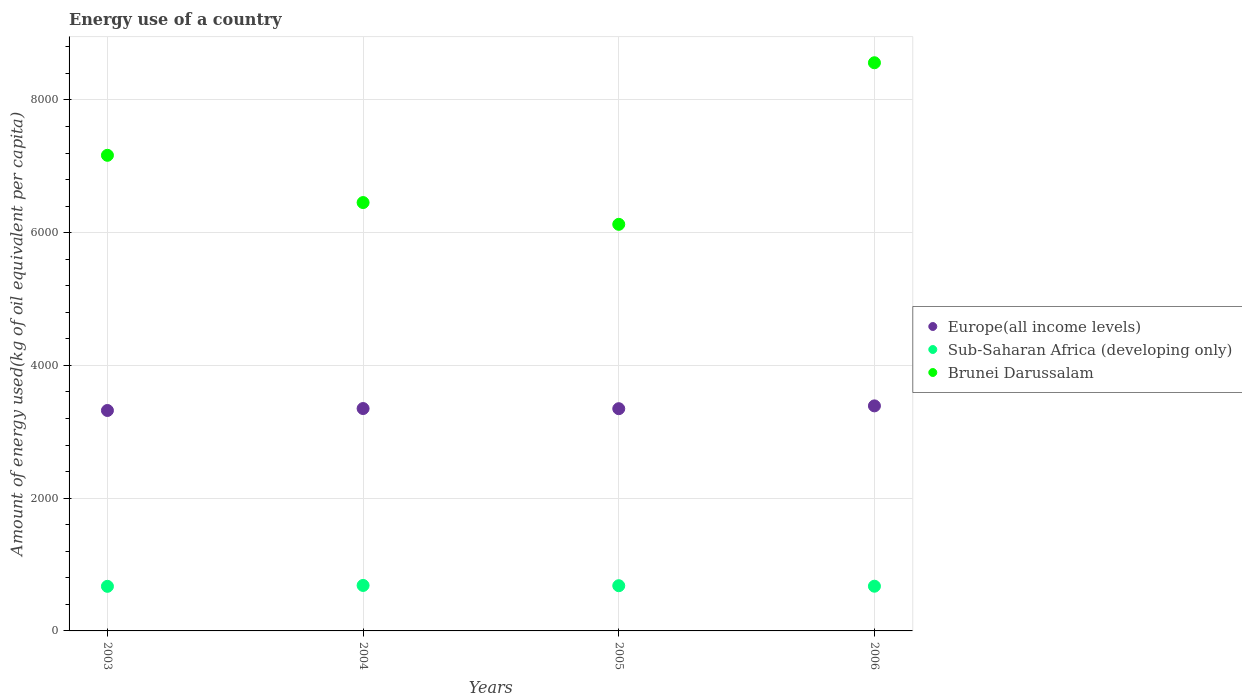How many different coloured dotlines are there?
Make the answer very short. 3. Is the number of dotlines equal to the number of legend labels?
Your answer should be compact. Yes. What is the amount of energy used in in Europe(all income levels) in 2005?
Provide a succinct answer. 3348.29. Across all years, what is the maximum amount of energy used in in Europe(all income levels)?
Give a very brief answer. 3390.69. Across all years, what is the minimum amount of energy used in in Sub-Saharan Africa (developing only)?
Your answer should be compact. 671.88. In which year was the amount of energy used in in Brunei Darussalam maximum?
Offer a very short reply. 2006. What is the total amount of energy used in in Brunei Darussalam in the graph?
Make the answer very short. 2.83e+04. What is the difference between the amount of energy used in in Brunei Darussalam in 2003 and that in 2006?
Keep it short and to the point. -1394.4. What is the difference between the amount of energy used in in Brunei Darussalam in 2004 and the amount of energy used in in Sub-Saharan Africa (developing only) in 2003?
Ensure brevity in your answer.  5782.13. What is the average amount of energy used in in Brunei Darussalam per year?
Your answer should be compact. 7076.58. In the year 2005, what is the difference between the amount of energy used in in Brunei Darussalam and amount of energy used in in Sub-Saharan Africa (developing only)?
Keep it short and to the point. 5444.76. What is the ratio of the amount of energy used in in Brunei Darussalam in 2004 to that in 2006?
Provide a short and direct response. 0.75. Is the amount of energy used in in Europe(all income levels) in 2004 less than that in 2005?
Offer a very short reply. No. What is the difference between the highest and the second highest amount of energy used in in Brunei Darussalam?
Offer a terse response. 1394.4. What is the difference between the highest and the lowest amount of energy used in in Brunei Darussalam?
Ensure brevity in your answer.  2434.55. In how many years, is the amount of energy used in in Europe(all income levels) greater than the average amount of energy used in in Europe(all income levels) taken over all years?
Offer a terse response. 1. Is the amount of energy used in in Brunei Darussalam strictly greater than the amount of energy used in in Sub-Saharan Africa (developing only) over the years?
Make the answer very short. Yes. How many dotlines are there?
Offer a terse response. 3. Are the values on the major ticks of Y-axis written in scientific E-notation?
Your answer should be very brief. No. Does the graph contain grids?
Make the answer very short. Yes. Where does the legend appear in the graph?
Your answer should be compact. Center right. How many legend labels are there?
Your answer should be compact. 3. What is the title of the graph?
Your response must be concise. Energy use of a country. Does "Zimbabwe" appear as one of the legend labels in the graph?
Provide a succinct answer. No. What is the label or title of the X-axis?
Your answer should be very brief. Years. What is the label or title of the Y-axis?
Provide a succinct answer. Amount of energy used(kg of oil equivalent per capita). What is the Amount of energy used(kg of oil equivalent per capita) of Europe(all income levels) in 2003?
Give a very brief answer. 3321.23. What is the Amount of energy used(kg of oil equivalent per capita) of Sub-Saharan Africa (developing only) in 2003?
Offer a terse response. 671.88. What is the Amount of energy used(kg of oil equivalent per capita) in Brunei Darussalam in 2003?
Give a very brief answer. 7166.03. What is the Amount of energy used(kg of oil equivalent per capita) in Europe(all income levels) in 2004?
Give a very brief answer. 3350.61. What is the Amount of energy used(kg of oil equivalent per capita) of Sub-Saharan Africa (developing only) in 2004?
Your response must be concise. 685.23. What is the Amount of energy used(kg of oil equivalent per capita) of Brunei Darussalam in 2004?
Ensure brevity in your answer.  6454. What is the Amount of energy used(kg of oil equivalent per capita) of Europe(all income levels) in 2005?
Give a very brief answer. 3348.29. What is the Amount of energy used(kg of oil equivalent per capita) in Sub-Saharan Africa (developing only) in 2005?
Give a very brief answer. 681.12. What is the Amount of energy used(kg of oil equivalent per capita) in Brunei Darussalam in 2005?
Provide a short and direct response. 6125.88. What is the Amount of energy used(kg of oil equivalent per capita) of Europe(all income levels) in 2006?
Your answer should be very brief. 3390.69. What is the Amount of energy used(kg of oil equivalent per capita) in Sub-Saharan Africa (developing only) in 2006?
Your response must be concise. 673.61. What is the Amount of energy used(kg of oil equivalent per capita) in Brunei Darussalam in 2006?
Your answer should be very brief. 8560.43. Across all years, what is the maximum Amount of energy used(kg of oil equivalent per capita) of Europe(all income levels)?
Make the answer very short. 3390.69. Across all years, what is the maximum Amount of energy used(kg of oil equivalent per capita) in Sub-Saharan Africa (developing only)?
Your response must be concise. 685.23. Across all years, what is the maximum Amount of energy used(kg of oil equivalent per capita) in Brunei Darussalam?
Offer a very short reply. 8560.43. Across all years, what is the minimum Amount of energy used(kg of oil equivalent per capita) in Europe(all income levels)?
Your response must be concise. 3321.23. Across all years, what is the minimum Amount of energy used(kg of oil equivalent per capita) of Sub-Saharan Africa (developing only)?
Your response must be concise. 671.88. Across all years, what is the minimum Amount of energy used(kg of oil equivalent per capita) in Brunei Darussalam?
Your answer should be compact. 6125.88. What is the total Amount of energy used(kg of oil equivalent per capita) of Europe(all income levels) in the graph?
Ensure brevity in your answer.  1.34e+04. What is the total Amount of energy used(kg of oil equivalent per capita) of Sub-Saharan Africa (developing only) in the graph?
Provide a succinct answer. 2711.84. What is the total Amount of energy used(kg of oil equivalent per capita) in Brunei Darussalam in the graph?
Your answer should be compact. 2.83e+04. What is the difference between the Amount of energy used(kg of oil equivalent per capita) in Europe(all income levels) in 2003 and that in 2004?
Offer a terse response. -29.38. What is the difference between the Amount of energy used(kg of oil equivalent per capita) of Sub-Saharan Africa (developing only) in 2003 and that in 2004?
Offer a very short reply. -13.36. What is the difference between the Amount of energy used(kg of oil equivalent per capita) of Brunei Darussalam in 2003 and that in 2004?
Make the answer very short. 712.02. What is the difference between the Amount of energy used(kg of oil equivalent per capita) of Europe(all income levels) in 2003 and that in 2005?
Give a very brief answer. -27.07. What is the difference between the Amount of energy used(kg of oil equivalent per capita) in Sub-Saharan Africa (developing only) in 2003 and that in 2005?
Give a very brief answer. -9.25. What is the difference between the Amount of energy used(kg of oil equivalent per capita) of Brunei Darussalam in 2003 and that in 2005?
Ensure brevity in your answer.  1040.15. What is the difference between the Amount of energy used(kg of oil equivalent per capita) of Europe(all income levels) in 2003 and that in 2006?
Provide a short and direct response. -69.46. What is the difference between the Amount of energy used(kg of oil equivalent per capita) in Sub-Saharan Africa (developing only) in 2003 and that in 2006?
Keep it short and to the point. -1.74. What is the difference between the Amount of energy used(kg of oil equivalent per capita) of Brunei Darussalam in 2003 and that in 2006?
Offer a very short reply. -1394.4. What is the difference between the Amount of energy used(kg of oil equivalent per capita) in Europe(all income levels) in 2004 and that in 2005?
Offer a terse response. 2.31. What is the difference between the Amount of energy used(kg of oil equivalent per capita) of Sub-Saharan Africa (developing only) in 2004 and that in 2005?
Your answer should be very brief. 4.11. What is the difference between the Amount of energy used(kg of oil equivalent per capita) in Brunei Darussalam in 2004 and that in 2005?
Make the answer very short. 328.12. What is the difference between the Amount of energy used(kg of oil equivalent per capita) of Europe(all income levels) in 2004 and that in 2006?
Your answer should be very brief. -40.08. What is the difference between the Amount of energy used(kg of oil equivalent per capita) in Sub-Saharan Africa (developing only) in 2004 and that in 2006?
Give a very brief answer. 11.62. What is the difference between the Amount of energy used(kg of oil equivalent per capita) in Brunei Darussalam in 2004 and that in 2006?
Your response must be concise. -2106.42. What is the difference between the Amount of energy used(kg of oil equivalent per capita) in Europe(all income levels) in 2005 and that in 2006?
Your answer should be compact. -42.39. What is the difference between the Amount of energy used(kg of oil equivalent per capita) in Sub-Saharan Africa (developing only) in 2005 and that in 2006?
Provide a succinct answer. 7.51. What is the difference between the Amount of energy used(kg of oil equivalent per capita) of Brunei Darussalam in 2005 and that in 2006?
Give a very brief answer. -2434.55. What is the difference between the Amount of energy used(kg of oil equivalent per capita) of Europe(all income levels) in 2003 and the Amount of energy used(kg of oil equivalent per capita) of Sub-Saharan Africa (developing only) in 2004?
Your response must be concise. 2635.99. What is the difference between the Amount of energy used(kg of oil equivalent per capita) of Europe(all income levels) in 2003 and the Amount of energy used(kg of oil equivalent per capita) of Brunei Darussalam in 2004?
Your answer should be compact. -3132.78. What is the difference between the Amount of energy used(kg of oil equivalent per capita) in Sub-Saharan Africa (developing only) in 2003 and the Amount of energy used(kg of oil equivalent per capita) in Brunei Darussalam in 2004?
Offer a very short reply. -5782.13. What is the difference between the Amount of energy used(kg of oil equivalent per capita) of Europe(all income levels) in 2003 and the Amount of energy used(kg of oil equivalent per capita) of Sub-Saharan Africa (developing only) in 2005?
Your answer should be very brief. 2640.1. What is the difference between the Amount of energy used(kg of oil equivalent per capita) in Europe(all income levels) in 2003 and the Amount of energy used(kg of oil equivalent per capita) in Brunei Darussalam in 2005?
Your answer should be very brief. -2804.66. What is the difference between the Amount of energy used(kg of oil equivalent per capita) of Sub-Saharan Africa (developing only) in 2003 and the Amount of energy used(kg of oil equivalent per capita) of Brunei Darussalam in 2005?
Provide a succinct answer. -5454.01. What is the difference between the Amount of energy used(kg of oil equivalent per capita) of Europe(all income levels) in 2003 and the Amount of energy used(kg of oil equivalent per capita) of Sub-Saharan Africa (developing only) in 2006?
Your answer should be compact. 2647.61. What is the difference between the Amount of energy used(kg of oil equivalent per capita) in Europe(all income levels) in 2003 and the Amount of energy used(kg of oil equivalent per capita) in Brunei Darussalam in 2006?
Offer a very short reply. -5239.2. What is the difference between the Amount of energy used(kg of oil equivalent per capita) in Sub-Saharan Africa (developing only) in 2003 and the Amount of energy used(kg of oil equivalent per capita) in Brunei Darussalam in 2006?
Your answer should be very brief. -7888.55. What is the difference between the Amount of energy used(kg of oil equivalent per capita) in Europe(all income levels) in 2004 and the Amount of energy used(kg of oil equivalent per capita) in Sub-Saharan Africa (developing only) in 2005?
Offer a very short reply. 2669.49. What is the difference between the Amount of energy used(kg of oil equivalent per capita) of Europe(all income levels) in 2004 and the Amount of energy used(kg of oil equivalent per capita) of Brunei Darussalam in 2005?
Offer a terse response. -2775.27. What is the difference between the Amount of energy used(kg of oil equivalent per capita) in Sub-Saharan Africa (developing only) in 2004 and the Amount of energy used(kg of oil equivalent per capita) in Brunei Darussalam in 2005?
Ensure brevity in your answer.  -5440.65. What is the difference between the Amount of energy used(kg of oil equivalent per capita) in Europe(all income levels) in 2004 and the Amount of energy used(kg of oil equivalent per capita) in Sub-Saharan Africa (developing only) in 2006?
Your answer should be compact. 2676.99. What is the difference between the Amount of energy used(kg of oil equivalent per capita) of Europe(all income levels) in 2004 and the Amount of energy used(kg of oil equivalent per capita) of Brunei Darussalam in 2006?
Give a very brief answer. -5209.82. What is the difference between the Amount of energy used(kg of oil equivalent per capita) in Sub-Saharan Africa (developing only) in 2004 and the Amount of energy used(kg of oil equivalent per capita) in Brunei Darussalam in 2006?
Make the answer very short. -7875.19. What is the difference between the Amount of energy used(kg of oil equivalent per capita) of Europe(all income levels) in 2005 and the Amount of energy used(kg of oil equivalent per capita) of Sub-Saharan Africa (developing only) in 2006?
Keep it short and to the point. 2674.68. What is the difference between the Amount of energy used(kg of oil equivalent per capita) in Europe(all income levels) in 2005 and the Amount of energy used(kg of oil equivalent per capita) in Brunei Darussalam in 2006?
Offer a terse response. -5212.13. What is the difference between the Amount of energy used(kg of oil equivalent per capita) in Sub-Saharan Africa (developing only) in 2005 and the Amount of energy used(kg of oil equivalent per capita) in Brunei Darussalam in 2006?
Give a very brief answer. -7879.31. What is the average Amount of energy used(kg of oil equivalent per capita) of Europe(all income levels) per year?
Make the answer very short. 3352.7. What is the average Amount of energy used(kg of oil equivalent per capita) of Sub-Saharan Africa (developing only) per year?
Your response must be concise. 677.96. What is the average Amount of energy used(kg of oil equivalent per capita) in Brunei Darussalam per year?
Offer a very short reply. 7076.58. In the year 2003, what is the difference between the Amount of energy used(kg of oil equivalent per capita) of Europe(all income levels) and Amount of energy used(kg of oil equivalent per capita) of Sub-Saharan Africa (developing only)?
Give a very brief answer. 2649.35. In the year 2003, what is the difference between the Amount of energy used(kg of oil equivalent per capita) of Europe(all income levels) and Amount of energy used(kg of oil equivalent per capita) of Brunei Darussalam?
Give a very brief answer. -3844.8. In the year 2003, what is the difference between the Amount of energy used(kg of oil equivalent per capita) of Sub-Saharan Africa (developing only) and Amount of energy used(kg of oil equivalent per capita) of Brunei Darussalam?
Offer a very short reply. -6494.15. In the year 2004, what is the difference between the Amount of energy used(kg of oil equivalent per capita) of Europe(all income levels) and Amount of energy used(kg of oil equivalent per capita) of Sub-Saharan Africa (developing only)?
Offer a terse response. 2665.38. In the year 2004, what is the difference between the Amount of energy used(kg of oil equivalent per capita) of Europe(all income levels) and Amount of energy used(kg of oil equivalent per capita) of Brunei Darussalam?
Keep it short and to the point. -3103.4. In the year 2004, what is the difference between the Amount of energy used(kg of oil equivalent per capita) of Sub-Saharan Africa (developing only) and Amount of energy used(kg of oil equivalent per capita) of Brunei Darussalam?
Give a very brief answer. -5768.77. In the year 2005, what is the difference between the Amount of energy used(kg of oil equivalent per capita) in Europe(all income levels) and Amount of energy used(kg of oil equivalent per capita) in Sub-Saharan Africa (developing only)?
Your answer should be very brief. 2667.17. In the year 2005, what is the difference between the Amount of energy used(kg of oil equivalent per capita) of Europe(all income levels) and Amount of energy used(kg of oil equivalent per capita) of Brunei Darussalam?
Ensure brevity in your answer.  -2777.59. In the year 2005, what is the difference between the Amount of energy used(kg of oil equivalent per capita) in Sub-Saharan Africa (developing only) and Amount of energy used(kg of oil equivalent per capita) in Brunei Darussalam?
Offer a terse response. -5444.76. In the year 2006, what is the difference between the Amount of energy used(kg of oil equivalent per capita) of Europe(all income levels) and Amount of energy used(kg of oil equivalent per capita) of Sub-Saharan Africa (developing only)?
Give a very brief answer. 2717.07. In the year 2006, what is the difference between the Amount of energy used(kg of oil equivalent per capita) in Europe(all income levels) and Amount of energy used(kg of oil equivalent per capita) in Brunei Darussalam?
Make the answer very short. -5169.74. In the year 2006, what is the difference between the Amount of energy used(kg of oil equivalent per capita) in Sub-Saharan Africa (developing only) and Amount of energy used(kg of oil equivalent per capita) in Brunei Darussalam?
Your response must be concise. -7886.81. What is the ratio of the Amount of energy used(kg of oil equivalent per capita) in Sub-Saharan Africa (developing only) in 2003 to that in 2004?
Your answer should be very brief. 0.98. What is the ratio of the Amount of energy used(kg of oil equivalent per capita) of Brunei Darussalam in 2003 to that in 2004?
Provide a succinct answer. 1.11. What is the ratio of the Amount of energy used(kg of oil equivalent per capita) of Europe(all income levels) in 2003 to that in 2005?
Your response must be concise. 0.99. What is the ratio of the Amount of energy used(kg of oil equivalent per capita) of Sub-Saharan Africa (developing only) in 2003 to that in 2005?
Offer a terse response. 0.99. What is the ratio of the Amount of energy used(kg of oil equivalent per capita) of Brunei Darussalam in 2003 to that in 2005?
Provide a short and direct response. 1.17. What is the ratio of the Amount of energy used(kg of oil equivalent per capita) of Europe(all income levels) in 2003 to that in 2006?
Give a very brief answer. 0.98. What is the ratio of the Amount of energy used(kg of oil equivalent per capita) in Brunei Darussalam in 2003 to that in 2006?
Offer a terse response. 0.84. What is the ratio of the Amount of energy used(kg of oil equivalent per capita) of Europe(all income levels) in 2004 to that in 2005?
Provide a succinct answer. 1. What is the ratio of the Amount of energy used(kg of oil equivalent per capita) in Sub-Saharan Africa (developing only) in 2004 to that in 2005?
Make the answer very short. 1.01. What is the ratio of the Amount of energy used(kg of oil equivalent per capita) of Brunei Darussalam in 2004 to that in 2005?
Ensure brevity in your answer.  1.05. What is the ratio of the Amount of energy used(kg of oil equivalent per capita) of Sub-Saharan Africa (developing only) in 2004 to that in 2006?
Your response must be concise. 1.02. What is the ratio of the Amount of energy used(kg of oil equivalent per capita) of Brunei Darussalam in 2004 to that in 2006?
Your response must be concise. 0.75. What is the ratio of the Amount of energy used(kg of oil equivalent per capita) in Europe(all income levels) in 2005 to that in 2006?
Give a very brief answer. 0.99. What is the ratio of the Amount of energy used(kg of oil equivalent per capita) in Sub-Saharan Africa (developing only) in 2005 to that in 2006?
Make the answer very short. 1.01. What is the ratio of the Amount of energy used(kg of oil equivalent per capita) in Brunei Darussalam in 2005 to that in 2006?
Your answer should be very brief. 0.72. What is the difference between the highest and the second highest Amount of energy used(kg of oil equivalent per capita) in Europe(all income levels)?
Your answer should be compact. 40.08. What is the difference between the highest and the second highest Amount of energy used(kg of oil equivalent per capita) of Sub-Saharan Africa (developing only)?
Make the answer very short. 4.11. What is the difference between the highest and the second highest Amount of energy used(kg of oil equivalent per capita) in Brunei Darussalam?
Provide a short and direct response. 1394.4. What is the difference between the highest and the lowest Amount of energy used(kg of oil equivalent per capita) in Europe(all income levels)?
Your answer should be compact. 69.46. What is the difference between the highest and the lowest Amount of energy used(kg of oil equivalent per capita) of Sub-Saharan Africa (developing only)?
Offer a very short reply. 13.36. What is the difference between the highest and the lowest Amount of energy used(kg of oil equivalent per capita) in Brunei Darussalam?
Provide a succinct answer. 2434.55. 